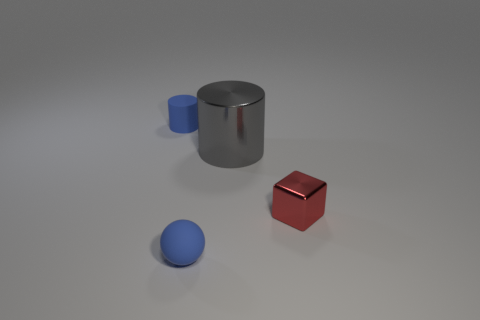Can you describe the lighting in the image? The lighting in the image is soft and diffused, creating gentle shadows beneath each object and giving the scene a calm and balanced ambience. 